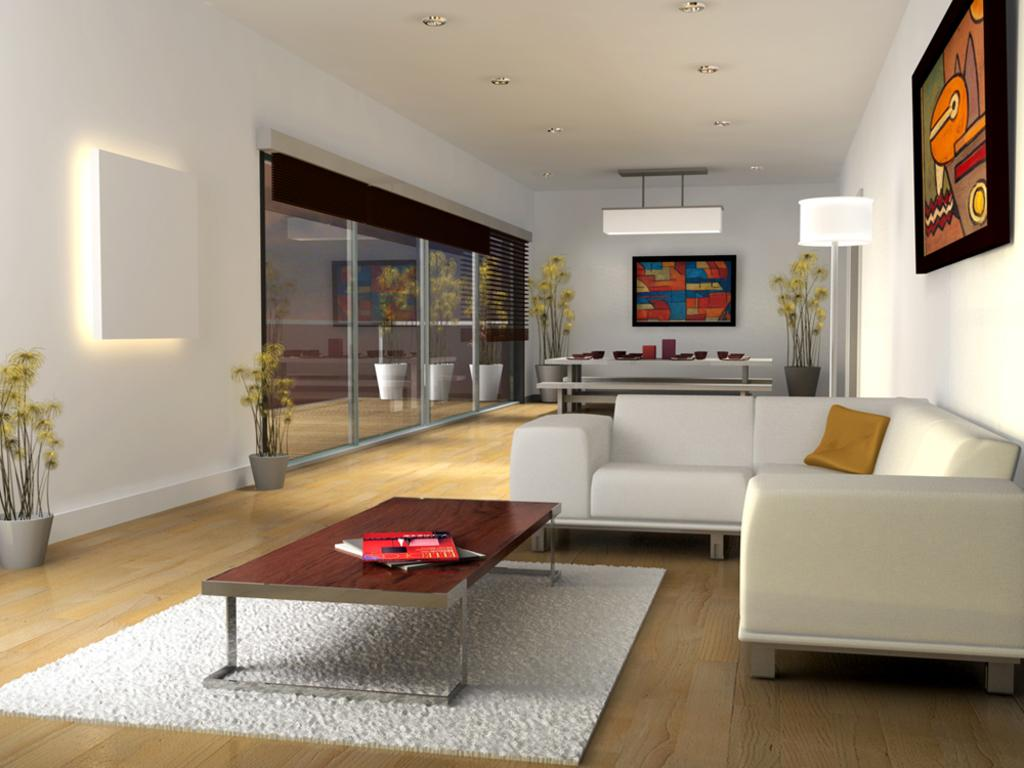What is the color of the wall in the image? The wall in the image is white. How many pots can be seen in the image? There are two pots in the image. What is hanging on the wall in the image? There is a banner in the image. What type of furniture is present in the image? There is a sofa and a table in the image. What items are on the table in the image? There are books on the table in the image. How is the celery being transported in the image? There is no celery present in the image, so it cannot be transported. What type of scale is visible on the sofa in the image? There is no scale present on the sofa or anywhere else in the image. 